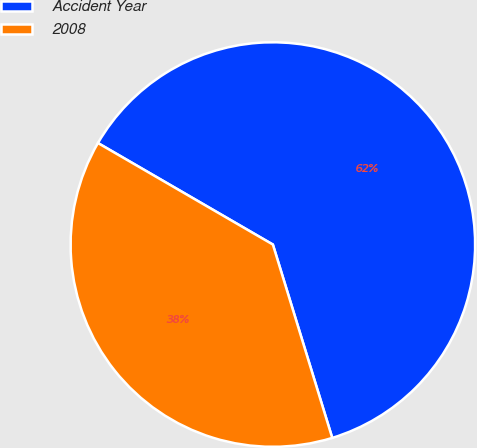Convert chart. <chart><loc_0><loc_0><loc_500><loc_500><pie_chart><fcel>Accident Year<fcel>2008<nl><fcel>61.89%<fcel>38.11%<nl></chart> 